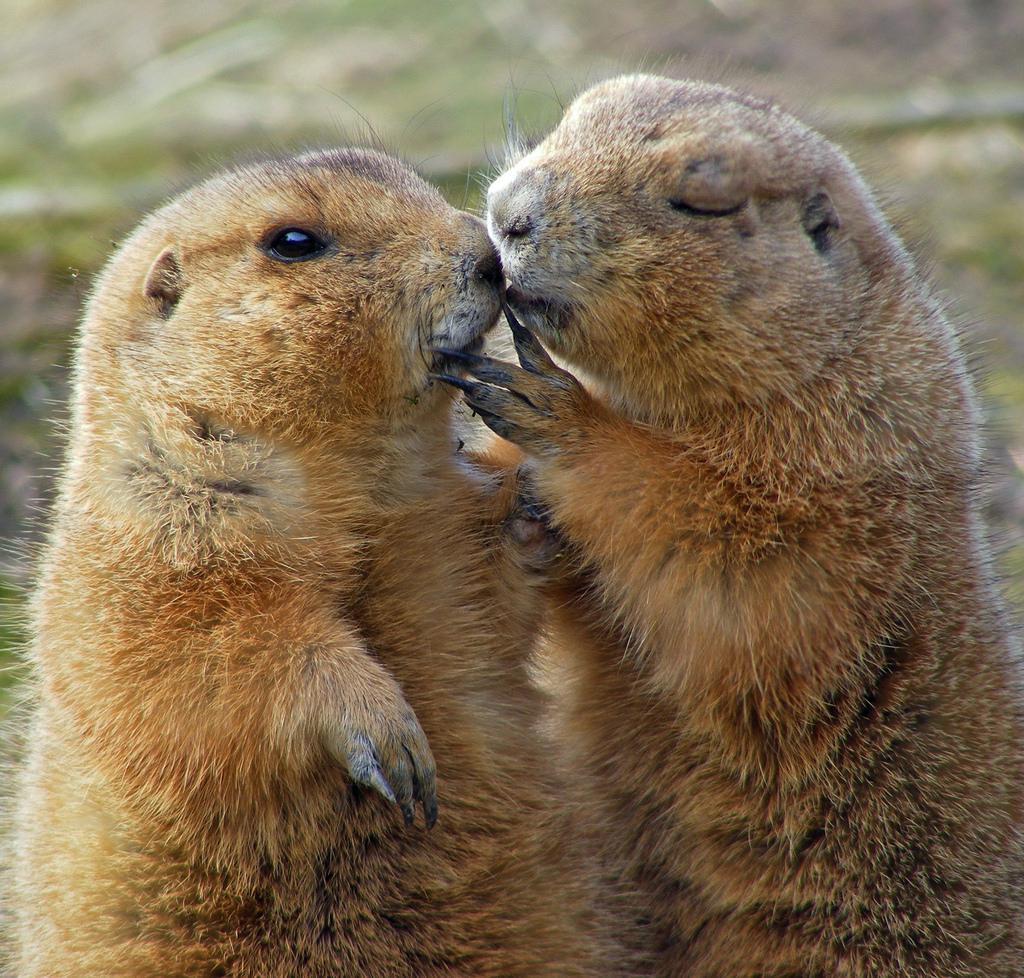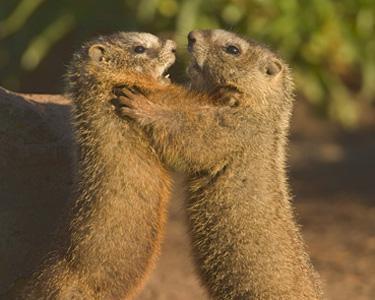The first image is the image on the left, the second image is the image on the right. Assess this claim about the two images: "Each image contains exactly one pair of marmots, and at least one pair is face-to-face.". Correct or not? Answer yes or no. Yes. The first image is the image on the left, the second image is the image on the right. Evaluate the accuracy of this statement regarding the images: "Two rodents interact together outside in each of the images.". Is it true? Answer yes or no. Yes. 